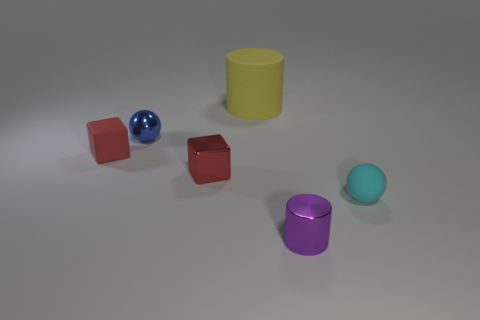Add 1 small red objects. How many objects exist? 7 Subtract all spheres. How many objects are left? 4 Add 5 gray rubber cylinders. How many gray rubber cylinders exist? 5 Subtract 0 blue blocks. How many objects are left? 6 Subtract all small balls. Subtract all yellow things. How many objects are left? 3 Add 5 tiny cyan rubber objects. How many tiny cyan rubber objects are left? 6 